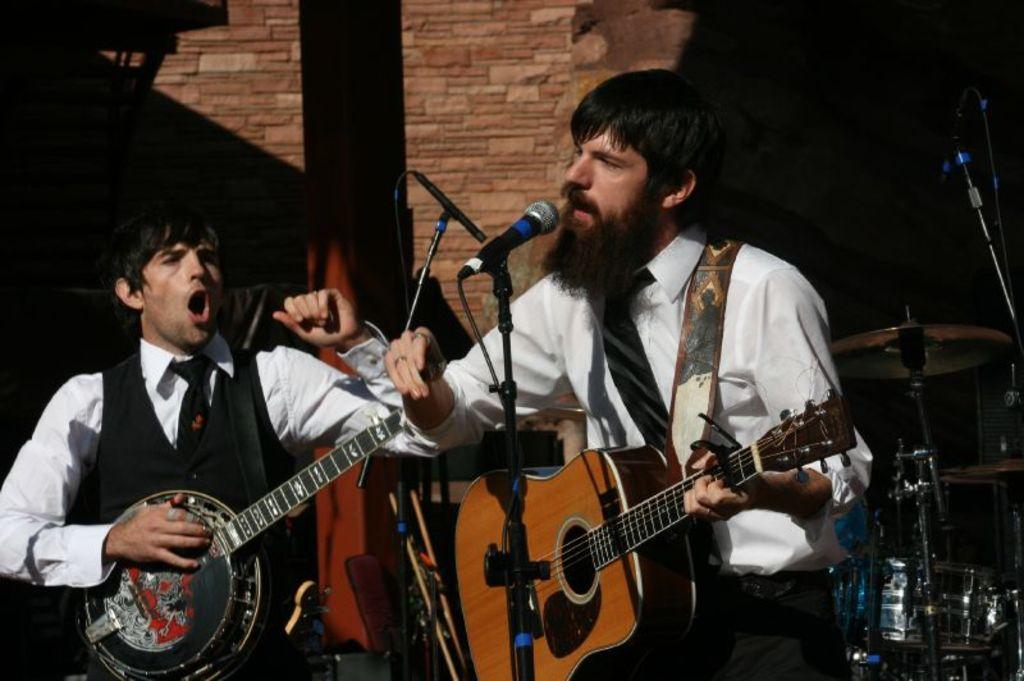Describe this image in one or two sentences. In this picture there are two people, they are standing at the center of the image, by holding the guitars in their hands and there is a mic in front of them, there is a drum set at the right side of the image. 